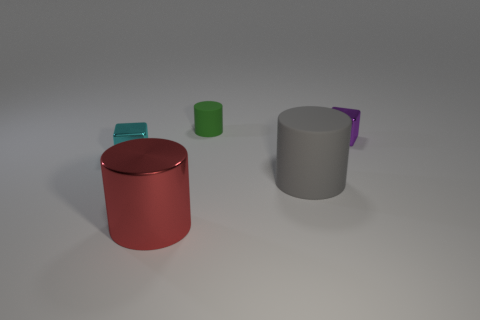Add 5 green cylinders. How many objects exist? 10 Subtract all cylinders. How many objects are left? 2 Add 4 matte things. How many matte things are left? 6 Add 2 green rubber things. How many green rubber things exist? 3 Subtract 0 red blocks. How many objects are left? 5 Subtract all large green rubber balls. Subtract all gray matte cylinders. How many objects are left? 4 